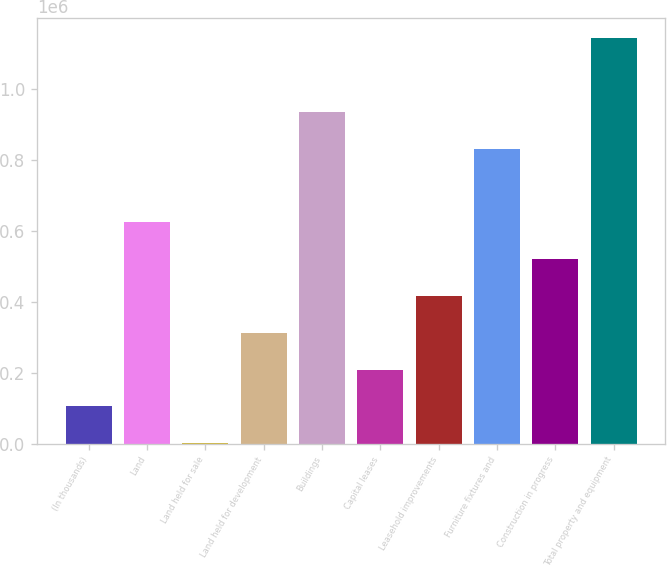<chart> <loc_0><loc_0><loc_500><loc_500><bar_chart><fcel>(In thousands)<fcel>Land<fcel>Land held for sale<fcel>Land held for development<fcel>Buildings<fcel>Capital leases<fcel>Leasehold improvements<fcel>Furniture fixtures and<fcel>Construction in progress<fcel>Total property and equipment<nl><fcel>104608<fcel>623043<fcel>921<fcel>311982<fcel>934104<fcel>208295<fcel>415669<fcel>830417<fcel>519356<fcel>1.14148e+06<nl></chart> 